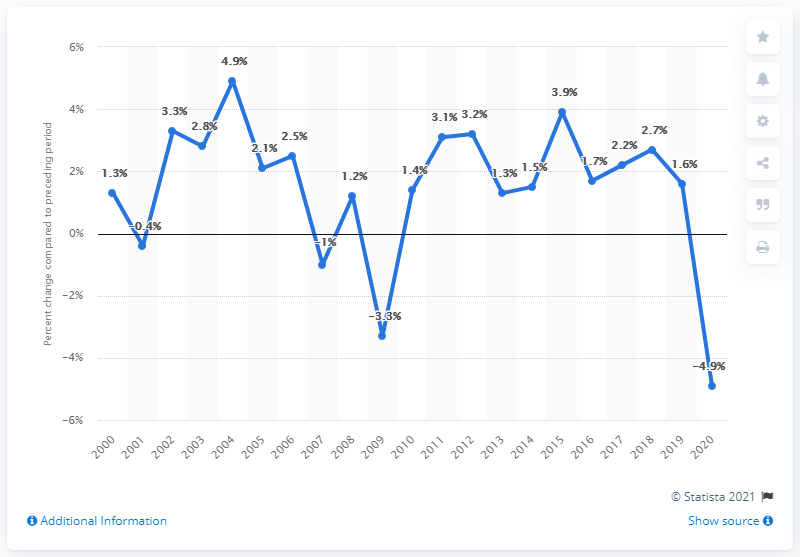Identify some key points in this picture. Tennessee's Gross Domestic Product (GDP) decreased by 4.9% in 2020. In 2004, the real Gross Domestic Product (GDP) of Tennessee experienced the most growth. 